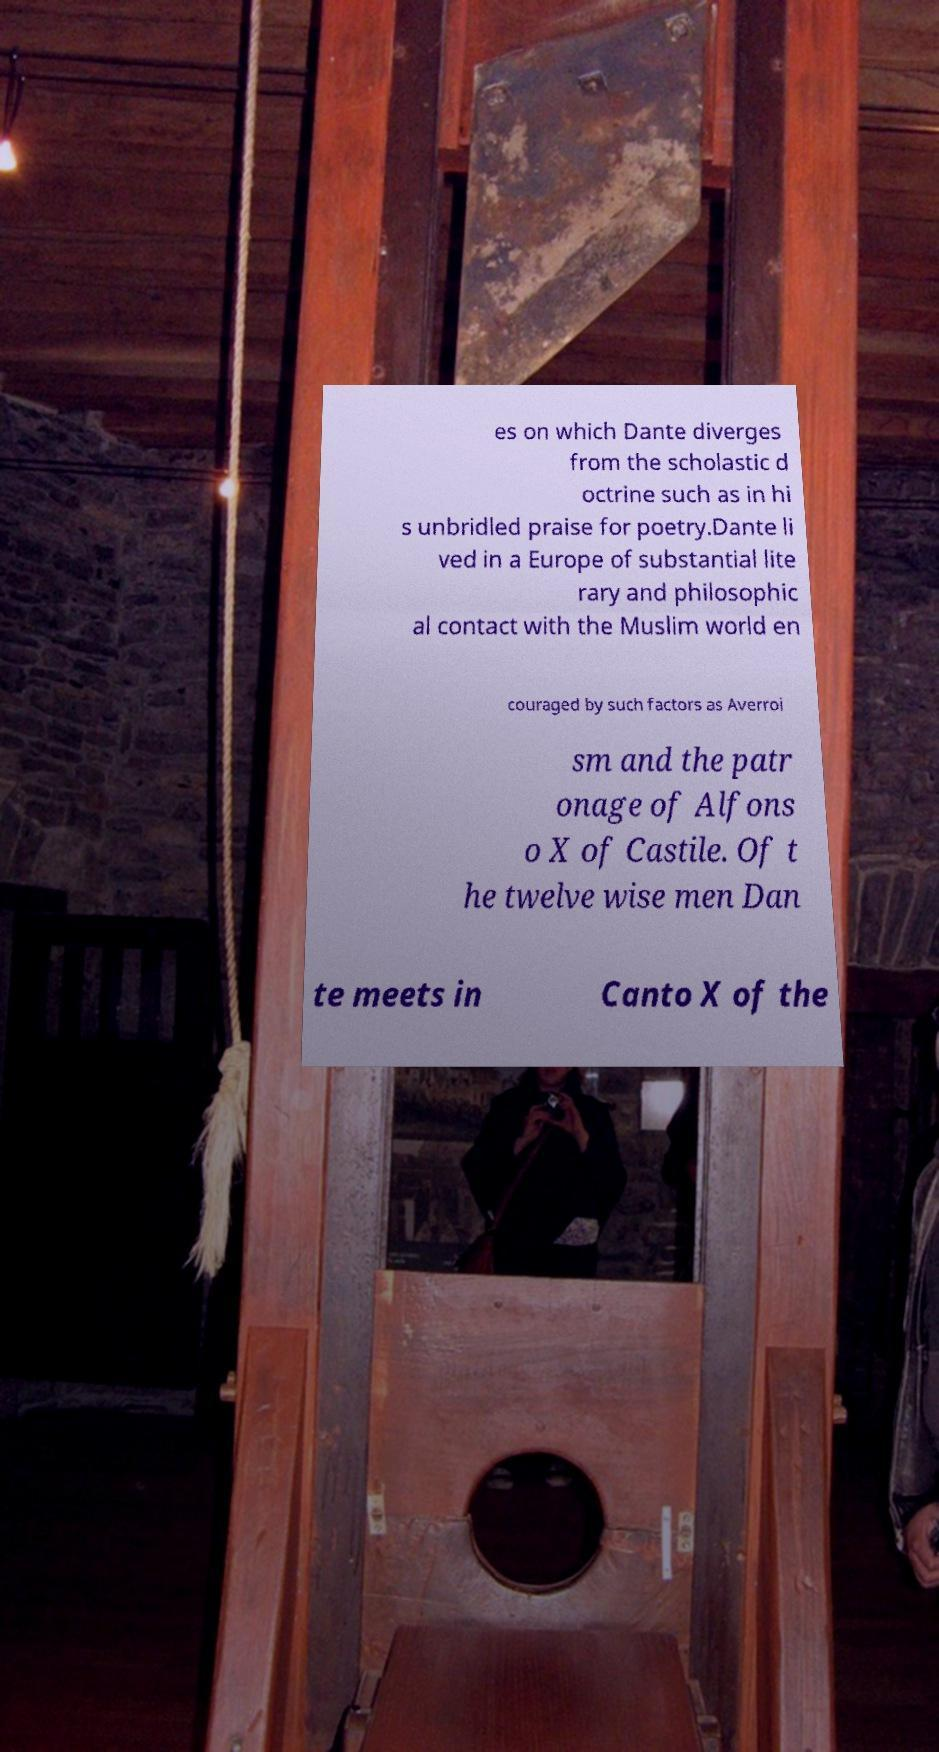There's text embedded in this image that I need extracted. Can you transcribe it verbatim? es on which Dante diverges from the scholastic d octrine such as in hi s unbridled praise for poetry.Dante li ved in a Europe of substantial lite rary and philosophic al contact with the Muslim world en couraged by such factors as Averroi sm and the patr onage of Alfons o X of Castile. Of t he twelve wise men Dan te meets in Canto X of the 